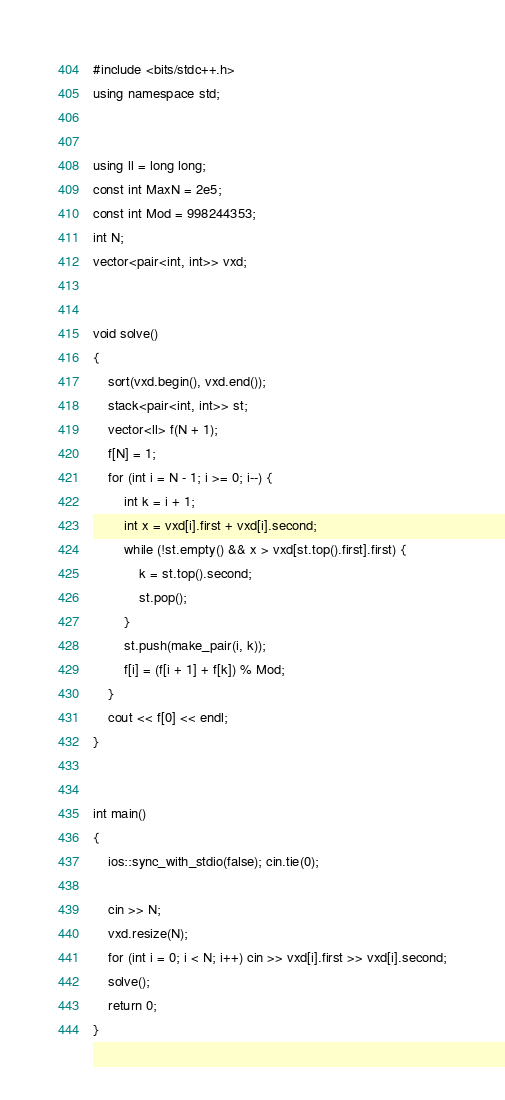<code> <loc_0><loc_0><loc_500><loc_500><_C++_>#include <bits/stdc++.h>
using namespace std;


using ll = long long;
const int MaxN = 2e5;
const int Mod = 998244353;
int N;
vector<pair<int, int>> vxd;


void solve()
{
    sort(vxd.begin(), vxd.end());
    stack<pair<int, int>> st;
    vector<ll> f(N + 1);
    f[N] = 1;
    for (int i = N - 1; i >= 0; i--) {
        int k = i + 1;
        int x = vxd[i].first + vxd[i].second;
        while (!st.empty() && x > vxd[st.top().first].first) {
            k = st.top().second;
            st.pop();
        }
        st.push(make_pair(i, k));
        f[i] = (f[i + 1] + f[k]) % Mod;
    }
    cout << f[0] << endl;
}


int main()
{
    ios::sync_with_stdio(false); cin.tie(0);

    cin >> N;
    vxd.resize(N);
    for (int i = 0; i < N; i++) cin >> vxd[i].first >> vxd[i].second;
    solve();
    return 0;
}
</code> 